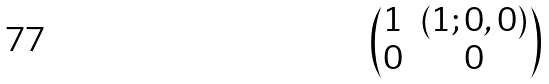Convert formula to latex. <formula><loc_0><loc_0><loc_500><loc_500>\begin{pmatrix} 1 & ( 1 ; 0 , 0 ) \\ 0 & 0 \end{pmatrix}</formula> 